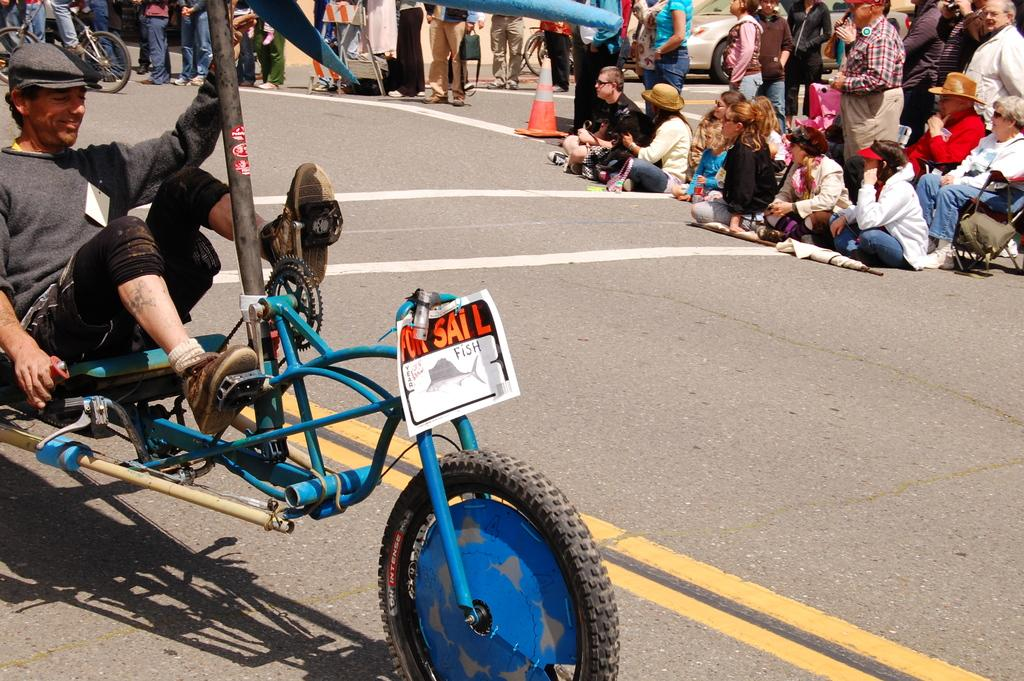What is the person in the image doing? The person is sitting on a vehicle and has placed their legs on the pedals in front of them. Can you describe the setting of the image? There are audience members in the background of the image. What type of apparel is the person wearing on their ring finger? There is no mention of apparel or rings in the image, so it cannot be determined what type of apparel the person might be wearing on their ring finger. 